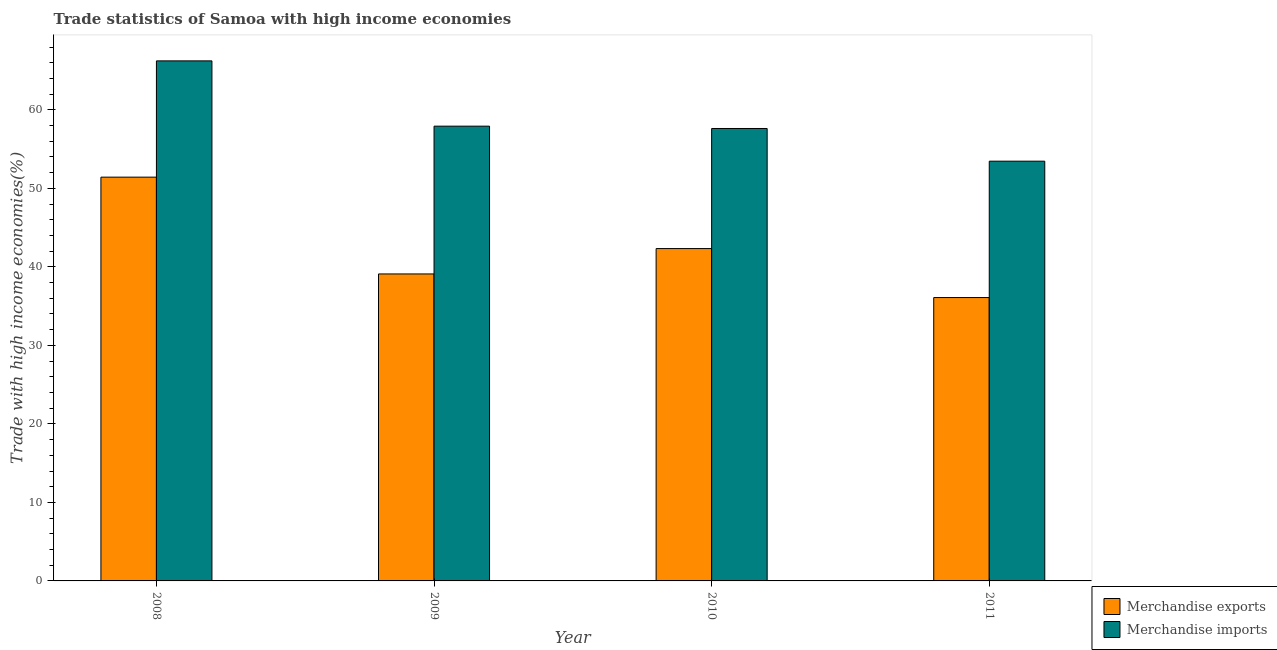How many different coloured bars are there?
Provide a succinct answer. 2. How many bars are there on the 1st tick from the left?
Keep it short and to the point. 2. What is the label of the 1st group of bars from the left?
Provide a short and direct response. 2008. In how many cases, is the number of bars for a given year not equal to the number of legend labels?
Your answer should be compact. 0. What is the merchandise imports in 2009?
Make the answer very short. 57.92. Across all years, what is the maximum merchandise exports?
Give a very brief answer. 51.43. Across all years, what is the minimum merchandise exports?
Provide a short and direct response. 36.09. In which year was the merchandise exports maximum?
Offer a terse response. 2008. What is the total merchandise imports in the graph?
Make the answer very short. 235.24. What is the difference between the merchandise exports in 2009 and that in 2010?
Your answer should be compact. -3.23. What is the difference between the merchandise imports in 2008 and the merchandise exports in 2010?
Make the answer very short. 8.61. What is the average merchandise imports per year?
Give a very brief answer. 58.81. In the year 2010, what is the difference between the merchandise imports and merchandise exports?
Your response must be concise. 0. In how many years, is the merchandise exports greater than 8 %?
Your answer should be very brief. 4. What is the ratio of the merchandise imports in 2009 to that in 2010?
Your answer should be very brief. 1.01. Is the merchandise imports in 2008 less than that in 2009?
Ensure brevity in your answer.  No. What is the difference between the highest and the second highest merchandise imports?
Make the answer very short. 8.32. What is the difference between the highest and the lowest merchandise imports?
Your answer should be very brief. 12.77. In how many years, is the merchandise exports greater than the average merchandise exports taken over all years?
Your answer should be very brief. 2. Is the sum of the merchandise imports in 2009 and 2011 greater than the maximum merchandise exports across all years?
Offer a very short reply. Yes. What does the 2nd bar from the left in 2010 represents?
Give a very brief answer. Merchandise imports. What does the 1st bar from the right in 2009 represents?
Provide a succinct answer. Merchandise imports. Are all the bars in the graph horizontal?
Offer a terse response. No. What is the difference between two consecutive major ticks on the Y-axis?
Provide a short and direct response. 10. Does the graph contain any zero values?
Provide a short and direct response. No. What is the title of the graph?
Offer a terse response. Trade statistics of Samoa with high income economies. What is the label or title of the X-axis?
Ensure brevity in your answer.  Year. What is the label or title of the Y-axis?
Provide a succinct answer. Trade with high income economies(%). What is the Trade with high income economies(%) of Merchandise exports in 2008?
Give a very brief answer. 51.43. What is the Trade with high income economies(%) of Merchandise imports in 2008?
Your answer should be compact. 66.23. What is the Trade with high income economies(%) in Merchandise exports in 2009?
Keep it short and to the point. 39.1. What is the Trade with high income economies(%) in Merchandise imports in 2009?
Provide a succinct answer. 57.92. What is the Trade with high income economies(%) of Merchandise exports in 2010?
Offer a very short reply. 42.33. What is the Trade with high income economies(%) in Merchandise imports in 2010?
Ensure brevity in your answer.  57.62. What is the Trade with high income economies(%) of Merchandise exports in 2011?
Your answer should be very brief. 36.09. What is the Trade with high income economies(%) of Merchandise imports in 2011?
Offer a terse response. 53.46. Across all years, what is the maximum Trade with high income economies(%) of Merchandise exports?
Give a very brief answer. 51.43. Across all years, what is the maximum Trade with high income economies(%) in Merchandise imports?
Offer a very short reply. 66.23. Across all years, what is the minimum Trade with high income economies(%) in Merchandise exports?
Make the answer very short. 36.09. Across all years, what is the minimum Trade with high income economies(%) of Merchandise imports?
Ensure brevity in your answer.  53.46. What is the total Trade with high income economies(%) of Merchandise exports in the graph?
Your response must be concise. 168.94. What is the total Trade with high income economies(%) of Merchandise imports in the graph?
Keep it short and to the point. 235.24. What is the difference between the Trade with high income economies(%) in Merchandise exports in 2008 and that in 2009?
Your response must be concise. 12.33. What is the difference between the Trade with high income economies(%) in Merchandise imports in 2008 and that in 2009?
Your answer should be very brief. 8.32. What is the difference between the Trade with high income economies(%) in Merchandise exports in 2008 and that in 2010?
Your answer should be very brief. 9.1. What is the difference between the Trade with high income economies(%) of Merchandise imports in 2008 and that in 2010?
Make the answer very short. 8.61. What is the difference between the Trade with high income economies(%) of Merchandise exports in 2008 and that in 2011?
Your answer should be compact. 15.34. What is the difference between the Trade with high income economies(%) of Merchandise imports in 2008 and that in 2011?
Keep it short and to the point. 12.78. What is the difference between the Trade with high income economies(%) in Merchandise exports in 2009 and that in 2010?
Your response must be concise. -3.23. What is the difference between the Trade with high income economies(%) in Merchandise imports in 2009 and that in 2010?
Your answer should be compact. 0.3. What is the difference between the Trade with high income economies(%) of Merchandise exports in 2009 and that in 2011?
Offer a very short reply. 3.01. What is the difference between the Trade with high income economies(%) in Merchandise imports in 2009 and that in 2011?
Your answer should be compact. 4.46. What is the difference between the Trade with high income economies(%) of Merchandise exports in 2010 and that in 2011?
Give a very brief answer. 6.24. What is the difference between the Trade with high income economies(%) of Merchandise imports in 2010 and that in 2011?
Give a very brief answer. 4.16. What is the difference between the Trade with high income economies(%) in Merchandise exports in 2008 and the Trade with high income economies(%) in Merchandise imports in 2009?
Ensure brevity in your answer.  -6.49. What is the difference between the Trade with high income economies(%) of Merchandise exports in 2008 and the Trade with high income economies(%) of Merchandise imports in 2010?
Make the answer very short. -6.2. What is the difference between the Trade with high income economies(%) in Merchandise exports in 2008 and the Trade with high income economies(%) in Merchandise imports in 2011?
Your answer should be very brief. -2.03. What is the difference between the Trade with high income economies(%) of Merchandise exports in 2009 and the Trade with high income economies(%) of Merchandise imports in 2010?
Your response must be concise. -18.52. What is the difference between the Trade with high income economies(%) of Merchandise exports in 2009 and the Trade with high income economies(%) of Merchandise imports in 2011?
Your answer should be compact. -14.36. What is the difference between the Trade with high income economies(%) in Merchandise exports in 2010 and the Trade with high income economies(%) in Merchandise imports in 2011?
Make the answer very short. -11.13. What is the average Trade with high income economies(%) in Merchandise exports per year?
Make the answer very short. 42.24. What is the average Trade with high income economies(%) in Merchandise imports per year?
Give a very brief answer. 58.81. In the year 2008, what is the difference between the Trade with high income economies(%) of Merchandise exports and Trade with high income economies(%) of Merchandise imports?
Provide a succinct answer. -14.81. In the year 2009, what is the difference between the Trade with high income economies(%) in Merchandise exports and Trade with high income economies(%) in Merchandise imports?
Your response must be concise. -18.82. In the year 2010, what is the difference between the Trade with high income economies(%) in Merchandise exports and Trade with high income economies(%) in Merchandise imports?
Keep it short and to the point. -15.29. In the year 2011, what is the difference between the Trade with high income economies(%) of Merchandise exports and Trade with high income economies(%) of Merchandise imports?
Offer a very short reply. -17.37. What is the ratio of the Trade with high income economies(%) in Merchandise exports in 2008 to that in 2009?
Make the answer very short. 1.32. What is the ratio of the Trade with high income economies(%) in Merchandise imports in 2008 to that in 2009?
Give a very brief answer. 1.14. What is the ratio of the Trade with high income economies(%) of Merchandise exports in 2008 to that in 2010?
Offer a terse response. 1.21. What is the ratio of the Trade with high income economies(%) in Merchandise imports in 2008 to that in 2010?
Offer a very short reply. 1.15. What is the ratio of the Trade with high income economies(%) of Merchandise exports in 2008 to that in 2011?
Give a very brief answer. 1.43. What is the ratio of the Trade with high income economies(%) in Merchandise imports in 2008 to that in 2011?
Your answer should be very brief. 1.24. What is the ratio of the Trade with high income economies(%) in Merchandise exports in 2009 to that in 2010?
Ensure brevity in your answer.  0.92. What is the ratio of the Trade with high income economies(%) of Merchandise imports in 2009 to that in 2010?
Provide a succinct answer. 1.01. What is the ratio of the Trade with high income economies(%) in Merchandise imports in 2009 to that in 2011?
Your answer should be very brief. 1.08. What is the ratio of the Trade with high income economies(%) of Merchandise exports in 2010 to that in 2011?
Your response must be concise. 1.17. What is the ratio of the Trade with high income economies(%) of Merchandise imports in 2010 to that in 2011?
Your answer should be very brief. 1.08. What is the difference between the highest and the second highest Trade with high income economies(%) in Merchandise exports?
Your answer should be compact. 9.1. What is the difference between the highest and the second highest Trade with high income economies(%) in Merchandise imports?
Your answer should be very brief. 8.32. What is the difference between the highest and the lowest Trade with high income economies(%) in Merchandise exports?
Provide a short and direct response. 15.34. What is the difference between the highest and the lowest Trade with high income economies(%) in Merchandise imports?
Ensure brevity in your answer.  12.78. 